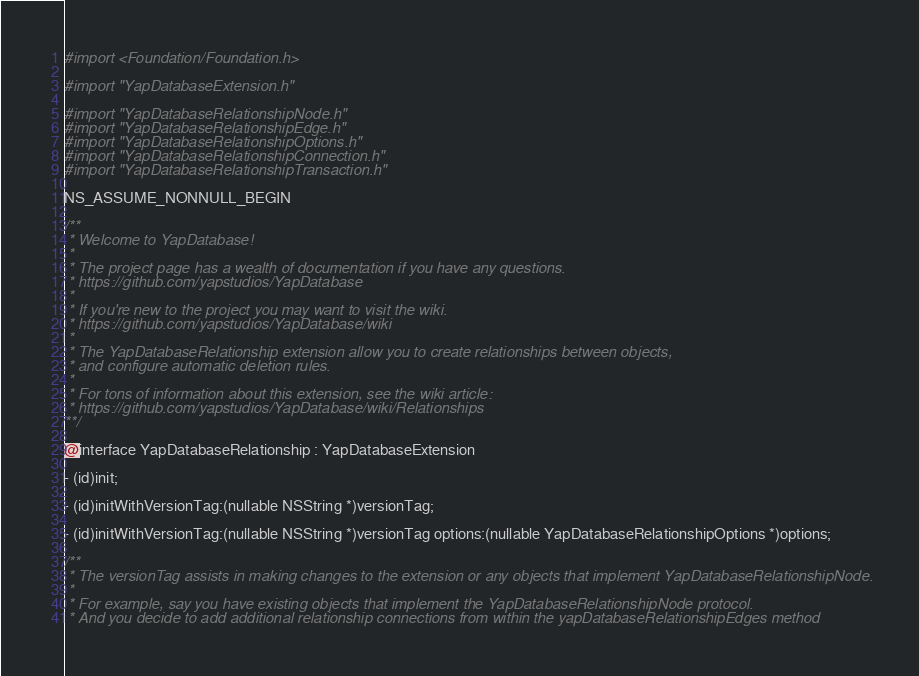<code> <loc_0><loc_0><loc_500><loc_500><_C_>#import <Foundation/Foundation.h>

#import "YapDatabaseExtension.h"

#import "YapDatabaseRelationshipNode.h"
#import "YapDatabaseRelationshipEdge.h"
#import "YapDatabaseRelationshipOptions.h"
#import "YapDatabaseRelationshipConnection.h"
#import "YapDatabaseRelationshipTransaction.h"

NS_ASSUME_NONNULL_BEGIN

/**
 * Welcome to YapDatabase!
 *
 * The project page has a wealth of documentation if you have any questions.
 * https://github.com/yapstudios/YapDatabase
 *
 * If you're new to the project you may want to visit the wiki.
 * https://github.com/yapstudios/YapDatabase/wiki
 *
 * The YapDatabaseRelationship extension allow you to create relationships between objects,
 * and configure automatic deletion rules.
 *
 * For tons of information about this extension, see the wiki article:
 * https://github.com/yapstudios/YapDatabase/wiki/Relationships
**/

@interface YapDatabaseRelationship : YapDatabaseExtension

- (id)init;

- (id)initWithVersionTag:(nullable NSString *)versionTag;

- (id)initWithVersionTag:(nullable NSString *)versionTag options:(nullable YapDatabaseRelationshipOptions *)options;

/**
 * The versionTag assists in making changes to the extension or any objects that implement YapDatabaseRelationshipNode.
 *
 * For example, say you have existing objects that implement the YapDatabaseRelationshipNode protocol.
 * And you decide to add additional relationship connections from within the yapDatabaseRelationshipEdges method</code> 